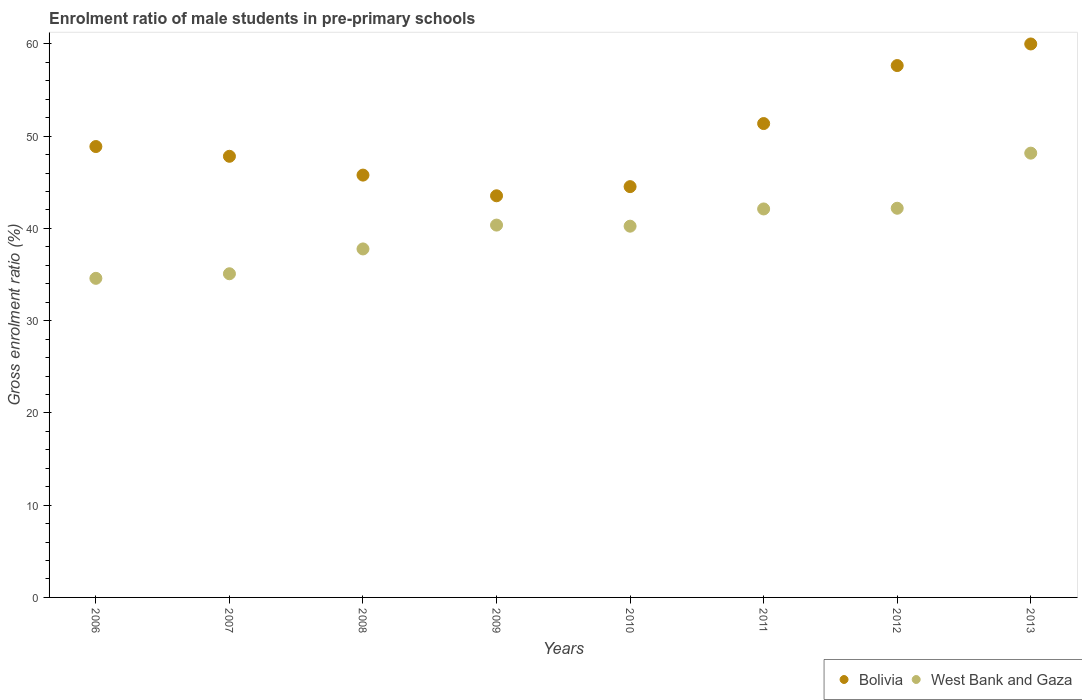How many different coloured dotlines are there?
Your response must be concise. 2. Is the number of dotlines equal to the number of legend labels?
Offer a very short reply. Yes. What is the enrolment ratio of male students in pre-primary schools in Bolivia in 2010?
Provide a succinct answer. 44.53. Across all years, what is the maximum enrolment ratio of male students in pre-primary schools in West Bank and Gaza?
Keep it short and to the point. 48.16. Across all years, what is the minimum enrolment ratio of male students in pre-primary schools in Bolivia?
Provide a short and direct response. 43.54. In which year was the enrolment ratio of male students in pre-primary schools in Bolivia minimum?
Keep it short and to the point. 2009. What is the total enrolment ratio of male students in pre-primary schools in Bolivia in the graph?
Your answer should be compact. 399.56. What is the difference between the enrolment ratio of male students in pre-primary schools in Bolivia in 2006 and that in 2008?
Ensure brevity in your answer.  3.1. What is the difference between the enrolment ratio of male students in pre-primary schools in West Bank and Gaza in 2006 and the enrolment ratio of male students in pre-primary schools in Bolivia in 2010?
Provide a succinct answer. -9.94. What is the average enrolment ratio of male students in pre-primary schools in West Bank and Gaza per year?
Your response must be concise. 40.06. In the year 2013, what is the difference between the enrolment ratio of male students in pre-primary schools in West Bank and Gaza and enrolment ratio of male students in pre-primary schools in Bolivia?
Keep it short and to the point. -11.83. In how many years, is the enrolment ratio of male students in pre-primary schools in Bolivia greater than 6 %?
Keep it short and to the point. 8. What is the ratio of the enrolment ratio of male students in pre-primary schools in West Bank and Gaza in 2008 to that in 2012?
Keep it short and to the point. 0.9. Is the enrolment ratio of male students in pre-primary schools in West Bank and Gaza in 2007 less than that in 2013?
Offer a terse response. Yes. What is the difference between the highest and the second highest enrolment ratio of male students in pre-primary schools in Bolivia?
Keep it short and to the point. 2.34. What is the difference between the highest and the lowest enrolment ratio of male students in pre-primary schools in West Bank and Gaza?
Offer a terse response. 13.57. In how many years, is the enrolment ratio of male students in pre-primary schools in West Bank and Gaza greater than the average enrolment ratio of male students in pre-primary schools in West Bank and Gaza taken over all years?
Provide a succinct answer. 5. Is the sum of the enrolment ratio of male students in pre-primary schools in West Bank and Gaza in 2008 and 2011 greater than the maximum enrolment ratio of male students in pre-primary schools in Bolivia across all years?
Offer a terse response. Yes. Does the enrolment ratio of male students in pre-primary schools in Bolivia monotonically increase over the years?
Your answer should be very brief. No. Is the enrolment ratio of male students in pre-primary schools in West Bank and Gaza strictly greater than the enrolment ratio of male students in pre-primary schools in Bolivia over the years?
Keep it short and to the point. No. How many dotlines are there?
Keep it short and to the point. 2. What is the difference between two consecutive major ticks on the Y-axis?
Make the answer very short. 10. Are the values on the major ticks of Y-axis written in scientific E-notation?
Make the answer very short. No. Where does the legend appear in the graph?
Offer a terse response. Bottom right. What is the title of the graph?
Your response must be concise. Enrolment ratio of male students in pre-primary schools. Does "Mexico" appear as one of the legend labels in the graph?
Offer a terse response. No. What is the label or title of the X-axis?
Your answer should be very brief. Years. What is the Gross enrolment ratio (%) of Bolivia in 2006?
Make the answer very short. 48.88. What is the Gross enrolment ratio (%) in West Bank and Gaza in 2006?
Keep it short and to the point. 34.59. What is the Gross enrolment ratio (%) in Bolivia in 2007?
Your answer should be compact. 47.82. What is the Gross enrolment ratio (%) of West Bank and Gaza in 2007?
Ensure brevity in your answer.  35.09. What is the Gross enrolment ratio (%) of Bolivia in 2008?
Provide a succinct answer. 45.78. What is the Gross enrolment ratio (%) of West Bank and Gaza in 2008?
Make the answer very short. 37.78. What is the Gross enrolment ratio (%) in Bolivia in 2009?
Keep it short and to the point. 43.54. What is the Gross enrolment ratio (%) of West Bank and Gaza in 2009?
Your answer should be compact. 40.36. What is the Gross enrolment ratio (%) of Bolivia in 2010?
Keep it short and to the point. 44.53. What is the Gross enrolment ratio (%) of West Bank and Gaza in 2010?
Keep it short and to the point. 40.24. What is the Gross enrolment ratio (%) of Bolivia in 2011?
Your answer should be very brief. 51.37. What is the Gross enrolment ratio (%) in West Bank and Gaza in 2011?
Provide a succinct answer. 42.11. What is the Gross enrolment ratio (%) in Bolivia in 2012?
Offer a very short reply. 57.65. What is the Gross enrolment ratio (%) in West Bank and Gaza in 2012?
Provide a succinct answer. 42.19. What is the Gross enrolment ratio (%) of Bolivia in 2013?
Provide a short and direct response. 59.99. What is the Gross enrolment ratio (%) of West Bank and Gaza in 2013?
Offer a terse response. 48.16. Across all years, what is the maximum Gross enrolment ratio (%) in Bolivia?
Make the answer very short. 59.99. Across all years, what is the maximum Gross enrolment ratio (%) of West Bank and Gaza?
Ensure brevity in your answer.  48.16. Across all years, what is the minimum Gross enrolment ratio (%) in Bolivia?
Ensure brevity in your answer.  43.54. Across all years, what is the minimum Gross enrolment ratio (%) in West Bank and Gaza?
Ensure brevity in your answer.  34.59. What is the total Gross enrolment ratio (%) of Bolivia in the graph?
Offer a very short reply. 399.56. What is the total Gross enrolment ratio (%) in West Bank and Gaza in the graph?
Offer a very short reply. 320.51. What is the difference between the Gross enrolment ratio (%) in Bolivia in 2006 and that in 2007?
Provide a succinct answer. 1.06. What is the difference between the Gross enrolment ratio (%) in West Bank and Gaza in 2006 and that in 2007?
Your answer should be compact. -0.5. What is the difference between the Gross enrolment ratio (%) in Bolivia in 2006 and that in 2008?
Keep it short and to the point. 3.1. What is the difference between the Gross enrolment ratio (%) of West Bank and Gaza in 2006 and that in 2008?
Your response must be concise. -3.19. What is the difference between the Gross enrolment ratio (%) in Bolivia in 2006 and that in 2009?
Provide a short and direct response. 5.34. What is the difference between the Gross enrolment ratio (%) in West Bank and Gaza in 2006 and that in 2009?
Your response must be concise. -5.77. What is the difference between the Gross enrolment ratio (%) in Bolivia in 2006 and that in 2010?
Keep it short and to the point. 4.35. What is the difference between the Gross enrolment ratio (%) of West Bank and Gaza in 2006 and that in 2010?
Provide a short and direct response. -5.65. What is the difference between the Gross enrolment ratio (%) in Bolivia in 2006 and that in 2011?
Provide a short and direct response. -2.49. What is the difference between the Gross enrolment ratio (%) of West Bank and Gaza in 2006 and that in 2011?
Provide a succinct answer. -7.52. What is the difference between the Gross enrolment ratio (%) in Bolivia in 2006 and that in 2012?
Offer a terse response. -8.78. What is the difference between the Gross enrolment ratio (%) of West Bank and Gaza in 2006 and that in 2012?
Your answer should be very brief. -7.6. What is the difference between the Gross enrolment ratio (%) in Bolivia in 2006 and that in 2013?
Your response must be concise. -11.12. What is the difference between the Gross enrolment ratio (%) of West Bank and Gaza in 2006 and that in 2013?
Ensure brevity in your answer.  -13.57. What is the difference between the Gross enrolment ratio (%) in Bolivia in 2007 and that in 2008?
Offer a terse response. 2.04. What is the difference between the Gross enrolment ratio (%) of West Bank and Gaza in 2007 and that in 2008?
Your response must be concise. -2.69. What is the difference between the Gross enrolment ratio (%) of Bolivia in 2007 and that in 2009?
Provide a succinct answer. 4.28. What is the difference between the Gross enrolment ratio (%) in West Bank and Gaza in 2007 and that in 2009?
Your answer should be compact. -5.28. What is the difference between the Gross enrolment ratio (%) of Bolivia in 2007 and that in 2010?
Your answer should be compact. 3.29. What is the difference between the Gross enrolment ratio (%) in West Bank and Gaza in 2007 and that in 2010?
Provide a succinct answer. -5.16. What is the difference between the Gross enrolment ratio (%) of Bolivia in 2007 and that in 2011?
Your answer should be very brief. -3.55. What is the difference between the Gross enrolment ratio (%) of West Bank and Gaza in 2007 and that in 2011?
Your response must be concise. -7.03. What is the difference between the Gross enrolment ratio (%) of Bolivia in 2007 and that in 2012?
Provide a short and direct response. -9.84. What is the difference between the Gross enrolment ratio (%) of West Bank and Gaza in 2007 and that in 2012?
Offer a very short reply. -7.1. What is the difference between the Gross enrolment ratio (%) of Bolivia in 2007 and that in 2013?
Your answer should be compact. -12.18. What is the difference between the Gross enrolment ratio (%) of West Bank and Gaza in 2007 and that in 2013?
Offer a very short reply. -13.07. What is the difference between the Gross enrolment ratio (%) in Bolivia in 2008 and that in 2009?
Provide a succinct answer. 2.24. What is the difference between the Gross enrolment ratio (%) in West Bank and Gaza in 2008 and that in 2009?
Ensure brevity in your answer.  -2.58. What is the difference between the Gross enrolment ratio (%) in Bolivia in 2008 and that in 2010?
Provide a succinct answer. 1.25. What is the difference between the Gross enrolment ratio (%) of West Bank and Gaza in 2008 and that in 2010?
Give a very brief answer. -2.47. What is the difference between the Gross enrolment ratio (%) of Bolivia in 2008 and that in 2011?
Offer a terse response. -5.59. What is the difference between the Gross enrolment ratio (%) of West Bank and Gaza in 2008 and that in 2011?
Your response must be concise. -4.33. What is the difference between the Gross enrolment ratio (%) in Bolivia in 2008 and that in 2012?
Your answer should be very brief. -11.87. What is the difference between the Gross enrolment ratio (%) in West Bank and Gaza in 2008 and that in 2012?
Provide a short and direct response. -4.41. What is the difference between the Gross enrolment ratio (%) in Bolivia in 2008 and that in 2013?
Keep it short and to the point. -14.21. What is the difference between the Gross enrolment ratio (%) in West Bank and Gaza in 2008 and that in 2013?
Offer a very short reply. -10.38. What is the difference between the Gross enrolment ratio (%) in Bolivia in 2009 and that in 2010?
Offer a terse response. -0.99. What is the difference between the Gross enrolment ratio (%) in West Bank and Gaza in 2009 and that in 2010?
Give a very brief answer. 0.12. What is the difference between the Gross enrolment ratio (%) in Bolivia in 2009 and that in 2011?
Offer a terse response. -7.83. What is the difference between the Gross enrolment ratio (%) of West Bank and Gaza in 2009 and that in 2011?
Keep it short and to the point. -1.75. What is the difference between the Gross enrolment ratio (%) of Bolivia in 2009 and that in 2012?
Your answer should be compact. -14.12. What is the difference between the Gross enrolment ratio (%) in West Bank and Gaza in 2009 and that in 2012?
Give a very brief answer. -1.82. What is the difference between the Gross enrolment ratio (%) of Bolivia in 2009 and that in 2013?
Ensure brevity in your answer.  -16.46. What is the difference between the Gross enrolment ratio (%) of West Bank and Gaza in 2009 and that in 2013?
Your answer should be very brief. -7.8. What is the difference between the Gross enrolment ratio (%) of Bolivia in 2010 and that in 2011?
Provide a succinct answer. -6.84. What is the difference between the Gross enrolment ratio (%) in West Bank and Gaza in 2010 and that in 2011?
Provide a short and direct response. -1.87. What is the difference between the Gross enrolment ratio (%) in Bolivia in 2010 and that in 2012?
Ensure brevity in your answer.  -13.12. What is the difference between the Gross enrolment ratio (%) of West Bank and Gaza in 2010 and that in 2012?
Offer a terse response. -1.94. What is the difference between the Gross enrolment ratio (%) of Bolivia in 2010 and that in 2013?
Give a very brief answer. -15.46. What is the difference between the Gross enrolment ratio (%) of West Bank and Gaza in 2010 and that in 2013?
Give a very brief answer. -7.92. What is the difference between the Gross enrolment ratio (%) in Bolivia in 2011 and that in 2012?
Your answer should be compact. -6.29. What is the difference between the Gross enrolment ratio (%) of West Bank and Gaza in 2011 and that in 2012?
Keep it short and to the point. -0.07. What is the difference between the Gross enrolment ratio (%) in Bolivia in 2011 and that in 2013?
Keep it short and to the point. -8.63. What is the difference between the Gross enrolment ratio (%) of West Bank and Gaza in 2011 and that in 2013?
Offer a very short reply. -6.05. What is the difference between the Gross enrolment ratio (%) of Bolivia in 2012 and that in 2013?
Give a very brief answer. -2.34. What is the difference between the Gross enrolment ratio (%) in West Bank and Gaza in 2012 and that in 2013?
Offer a very short reply. -5.97. What is the difference between the Gross enrolment ratio (%) of Bolivia in 2006 and the Gross enrolment ratio (%) of West Bank and Gaza in 2007?
Your response must be concise. 13.79. What is the difference between the Gross enrolment ratio (%) of Bolivia in 2006 and the Gross enrolment ratio (%) of West Bank and Gaza in 2008?
Your response must be concise. 11.1. What is the difference between the Gross enrolment ratio (%) in Bolivia in 2006 and the Gross enrolment ratio (%) in West Bank and Gaza in 2009?
Provide a short and direct response. 8.52. What is the difference between the Gross enrolment ratio (%) in Bolivia in 2006 and the Gross enrolment ratio (%) in West Bank and Gaza in 2010?
Ensure brevity in your answer.  8.63. What is the difference between the Gross enrolment ratio (%) in Bolivia in 2006 and the Gross enrolment ratio (%) in West Bank and Gaza in 2011?
Ensure brevity in your answer.  6.76. What is the difference between the Gross enrolment ratio (%) in Bolivia in 2006 and the Gross enrolment ratio (%) in West Bank and Gaza in 2012?
Keep it short and to the point. 6.69. What is the difference between the Gross enrolment ratio (%) of Bolivia in 2006 and the Gross enrolment ratio (%) of West Bank and Gaza in 2013?
Provide a short and direct response. 0.72. What is the difference between the Gross enrolment ratio (%) of Bolivia in 2007 and the Gross enrolment ratio (%) of West Bank and Gaza in 2008?
Provide a succinct answer. 10.04. What is the difference between the Gross enrolment ratio (%) in Bolivia in 2007 and the Gross enrolment ratio (%) in West Bank and Gaza in 2009?
Ensure brevity in your answer.  7.46. What is the difference between the Gross enrolment ratio (%) of Bolivia in 2007 and the Gross enrolment ratio (%) of West Bank and Gaza in 2010?
Keep it short and to the point. 7.58. What is the difference between the Gross enrolment ratio (%) of Bolivia in 2007 and the Gross enrolment ratio (%) of West Bank and Gaza in 2011?
Your answer should be compact. 5.71. What is the difference between the Gross enrolment ratio (%) of Bolivia in 2007 and the Gross enrolment ratio (%) of West Bank and Gaza in 2012?
Give a very brief answer. 5.63. What is the difference between the Gross enrolment ratio (%) in Bolivia in 2007 and the Gross enrolment ratio (%) in West Bank and Gaza in 2013?
Keep it short and to the point. -0.34. What is the difference between the Gross enrolment ratio (%) of Bolivia in 2008 and the Gross enrolment ratio (%) of West Bank and Gaza in 2009?
Offer a terse response. 5.42. What is the difference between the Gross enrolment ratio (%) in Bolivia in 2008 and the Gross enrolment ratio (%) in West Bank and Gaza in 2010?
Offer a very short reply. 5.54. What is the difference between the Gross enrolment ratio (%) in Bolivia in 2008 and the Gross enrolment ratio (%) in West Bank and Gaza in 2011?
Your response must be concise. 3.67. What is the difference between the Gross enrolment ratio (%) in Bolivia in 2008 and the Gross enrolment ratio (%) in West Bank and Gaza in 2012?
Keep it short and to the point. 3.59. What is the difference between the Gross enrolment ratio (%) of Bolivia in 2008 and the Gross enrolment ratio (%) of West Bank and Gaza in 2013?
Offer a terse response. -2.38. What is the difference between the Gross enrolment ratio (%) in Bolivia in 2009 and the Gross enrolment ratio (%) in West Bank and Gaza in 2010?
Give a very brief answer. 3.3. What is the difference between the Gross enrolment ratio (%) of Bolivia in 2009 and the Gross enrolment ratio (%) of West Bank and Gaza in 2011?
Provide a succinct answer. 1.43. What is the difference between the Gross enrolment ratio (%) in Bolivia in 2009 and the Gross enrolment ratio (%) in West Bank and Gaza in 2012?
Your answer should be compact. 1.35. What is the difference between the Gross enrolment ratio (%) in Bolivia in 2009 and the Gross enrolment ratio (%) in West Bank and Gaza in 2013?
Your answer should be compact. -4.62. What is the difference between the Gross enrolment ratio (%) of Bolivia in 2010 and the Gross enrolment ratio (%) of West Bank and Gaza in 2011?
Provide a short and direct response. 2.42. What is the difference between the Gross enrolment ratio (%) of Bolivia in 2010 and the Gross enrolment ratio (%) of West Bank and Gaza in 2012?
Offer a terse response. 2.34. What is the difference between the Gross enrolment ratio (%) in Bolivia in 2010 and the Gross enrolment ratio (%) in West Bank and Gaza in 2013?
Offer a very short reply. -3.63. What is the difference between the Gross enrolment ratio (%) of Bolivia in 2011 and the Gross enrolment ratio (%) of West Bank and Gaza in 2012?
Provide a succinct answer. 9.18. What is the difference between the Gross enrolment ratio (%) in Bolivia in 2011 and the Gross enrolment ratio (%) in West Bank and Gaza in 2013?
Keep it short and to the point. 3.21. What is the difference between the Gross enrolment ratio (%) in Bolivia in 2012 and the Gross enrolment ratio (%) in West Bank and Gaza in 2013?
Provide a short and direct response. 9.49. What is the average Gross enrolment ratio (%) in Bolivia per year?
Your answer should be very brief. 49.94. What is the average Gross enrolment ratio (%) in West Bank and Gaza per year?
Make the answer very short. 40.06. In the year 2006, what is the difference between the Gross enrolment ratio (%) of Bolivia and Gross enrolment ratio (%) of West Bank and Gaza?
Your answer should be compact. 14.29. In the year 2007, what is the difference between the Gross enrolment ratio (%) of Bolivia and Gross enrolment ratio (%) of West Bank and Gaza?
Ensure brevity in your answer.  12.73. In the year 2008, what is the difference between the Gross enrolment ratio (%) of Bolivia and Gross enrolment ratio (%) of West Bank and Gaza?
Your answer should be compact. 8. In the year 2009, what is the difference between the Gross enrolment ratio (%) in Bolivia and Gross enrolment ratio (%) in West Bank and Gaza?
Your response must be concise. 3.18. In the year 2010, what is the difference between the Gross enrolment ratio (%) in Bolivia and Gross enrolment ratio (%) in West Bank and Gaza?
Keep it short and to the point. 4.29. In the year 2011, what is the difference between the Gross enrolment ratio (%) of Bolivia and Gross enrolment ratio (%) of West Bank and Gaza?
Offer a very short reply. 9.26. In the year 2012, what is the difference between the Gross enrolment ratio (%) of Bolivia and Gross enrolment ratio (%) of West Bank and Gaza?
Keep it short and to the point. 15.47. In the year 2013, what is the difference between the Gross enrolment ratio (%) of Bolivia and Gross enrolment ratio (%) of West Bank and Gaza?
Offer a terse response. 11.84. What is the ratio of the Gross enrolment ratio (%) of Bolivia in 2006 to that in 2007?
Offer a very short reply. 1.02. What is the ratio of the Gross enrolment ratio (%) of West Bank and Gaza in 2006 to that in 2007?
Give a very brief answer. 0.99. What is the ratio of the Gross enrolment ratio (%) of Bolivia in 2006 to that in 2008?
Keep it short and to the point. 1.07. What is the ratio of the Gross enrolment ratio (%) of West Bank and Gaza in 2006 to that in 2008?
Give a very brief answer. 0.92. What is the ratio of the Gross enrolment ratio (%) of Bolivia in 2006 to that in 2009?
Provide a short and direct response. 1.12. What is the ratio of the Gross enrolment ratio (%) in West Bank and Gaza in 2006 to that in 2009?
Make the answer very short. 0.86. What is the ratio of the Gross enrolment ratio (%) in Bolivia in 2006 to that in 2010?
Provide a short and direct response. 1.1. What is the ratio of the Gross enrolment ratio (%) in West Bank and Gaza in 2006 to that in 2010?
Offer a very short reply. 0.86. What is the ratio of the Gross enrolment ratio (%) of Bolivia in 2006 to that in 2011?
Ensure brevity in your answer.  0.95. What is the ratio of the Gross enrolment ratio (%) in West Bank and Gaza in 2006 to that in 2011?
Give a very brief answer. 0.82. What is the ratio of the Gross enrolment ratio (%) in Bolivia in 2006 to that in 2012?
Keep it short and to the point. 0.85. What is the ratio of the Gross enrolment ratio (%) in West Bank and Gaza in 2006 to that in 2012?
Your answer should be compact. 0.82. What is the ratio of the Gross enrolment ratio (%) of Bolivia in 2006 to that in 2013?
Your answer should be compact. 0.81. What is the ratio of the Gross enrolment ratio (%) of West Bank and Gaza in 2006 to that in 2013?
Your answer should be compact. 0.72. What is the ratio of the Gross enrolment ratio (%) in Bolivia in 2007 to that in 2008?
Provide a succinct answer. 1.04. What is the ratio of the Gross enrolment ratio (%) in West Bank and Gaza in 2007 to that in 2008?
Give a very brief answer. 0.93. What is the ratio of the Gross enrolment ratio (%) of Bolivia in 2007 to that in 2009?
Give a very brief answer. 1.1. What is the ratio of the Gross enrolment ratio (%) in West Bank and Gaza in 2007 to that in 2009?
Ensure brevity in your answer.  0.87. What is the ratio of the Gross enrolment ratio (%) in Bolivia in 2007 to that in 2010?
Make the answer very short. 1.07. What is the ratio of the Gross enrolment ratio (%) in West Bank and Gaza in 2007 to that in 2010?
Offer a terse response. 0.87. What is the ratio of the Gross enrolment ratio (%) of Bolivia in 2007 to that in 2011?
Your answer should be very brief. 0.93. What is the ratio of the Gross enrolment ratio (%) in West Bank and Gaza in 2007 to that in 2011?
Your answer should be compact. 0.83. What is the ratio of the Gross enrolment ratio (%) of Bolivia in 2007 to that in 2012?
Make the answer very short. 0.83. What is the ratio of the Gross enrolment ratio (%) of West Bank and Gaza in 2007 to that in 2012?
Offer a terse response. 0.83. What is the ratio of the Gross enrolment ratio (%) of Bolivia in 2007 to that in 2013?
Offer a terse response. 0.8. What is the ratio of the Gross enrolment ratio (%) in West Bank and Gaza in 2007 to that in 2013?
Offer a very short reply. 0.73. What is the ratio of the Gross enrolment ratio (%) in Bolivia in 2008 to that in 2009?
Your answer should be very brief. 1.05. What is the ratio of the Gross enrolment ratio (%) of West Bank and Gaza in 2008 to that in 2009?
Offer a very short reply. 0.94. What is the ratio of the Gross enrolment ratio (%) in Bolivia in 2008 to that in 2010?
Provide a succinct answer. 1.03. What is the ratio of the Gross enrolment ratio (%) in West Bank and Gaza in 2008 to that in 2010?
Give a very brief answer. 0.94. What is the ratio of the Gross enrolment ratio (%) in Bolivia in 2008 to that in 2011?
Your answer should be compact. 0.89. What is the ratio of the Gross enrolment ratio (%) of West Bank and Gaza in 2008 to that in 2011?
Offer a very short reply. 0.9. What is the ratio of the Gross enrolment ratio (%) of Bolivia in 2008 to that in 2012?
Your response must be concise. 0.79. What is the ratio of the Gross enrolment ratio (%) in West Bank and Gaza in 2008 to that in 2012?
Give a very brief answer. 0.9. What is the ratio of the Gross enrolment ratio (%) in Bolivia in 2008 to that in 2013?
Make the answer very short. 0.76. What is the ratio of the Gross enrolment ratio (%) of West Bank and Gaza in 2008 to that in 2013?
Ensure brevity in your answer.  0.78. What is the ratio of the Gross enrolment ratio (%) in Bolivia in 2009 to that in 2010?
Your answer should be very brief. 0.98. What is the ratio of the Gross enrolment ratio (%) of Bolivia in 2009 to that in 2011?
Your answer should be very brief. 0.85. What is the ratio of the Gross enrolment ratio (%) in West Bank and Gaza in 2009 to that in 2011?
Offer a terse response. 0.96. What is the ratio of the Gross enrolment ratio (%) in Bolivia in 2009 to that in 2012?
Your answer should be very brief. 0.76. What is the ratio of the Gross enrolment ratio (%) of West Bank and Gaza in 2009 to that in 2012?
Offer a terse response. 0.96. What is the ratio of the Gross enrolment ratio (%) in Bolivia in 2009 to that in 2013?
Offer a very short reply. 0.73. What is the ratio of the Gross enrolment ratio (%) of West Bank and Gaza in 2009 to that in 2013?
Ensure brevity in your answer.  0.84. What is the ratio of the Gross enrolment ratio (%) in Bolivia in 2010 to that in 2011?
Offer a very short reply. 0.87. What is the ratio of the Gross enrolment ratio (%) of West Bank and Gaza in 2010 to that in 2011?
Offer a very short reply. 0.96. What is the ratio of the Gross enrolment ratio (%) in Bolivia in 2010 to that in 2012?
Your answer should be very brief. 0.77. What is the ratio of the Gross enrolment ratio (%) in West Bank and Gaza in 2010 to that in 2012?
Offer a very short reply. 0.95. What is the ratio of the Gross enrolment ratio (%) in Bolivia in 2010 to that in 2013?
Ensure brevity in your answer.  0.74. What is the ratio of the Gross enrolment ratio (%) of West Bank and Gaza in 2010 to that in 2013?
Your response must be concise. 0.84. What is the ratio of the Gross enrolment ratio (%) in Bolivia in 2011 to that in 2012?
Offer a terse response. 0.89. What is the ratio of the Gross enrolment ratio (%) of Bolivia in 2011 to that in 2013?
Your answer should be very brief. 0.86. What is the ratio of the Gross enrolment ratio (%) of West Bank and Gaza in 2011 to that in 2013?
Provide a succinct answer. 0.87. What is the ratio of the Gross enrolment ratio (%) of West Bank and Gaza in 2012 to that in 2013?
Offer a very short reply. 0.88. What is the difference between the highest and the second highest Gross enrolment ratio (%) of Bolivia?
Provide a succinct answer. 2.34. What is the difference between the highest and the second highest Gross enrolment ratio (%) in West Bank and Gaza?
Your answer should be compact. 5.97. What is the difference between the highest and the lowest Gross enrolment ratio (%) of Bolivia?
Offer a very short reply. 16.46. What is the difference between the highest and the lowest Gross enrolment ratio (%) of West Bank and Gaza?
Provide a short and direct response. 13.57. 